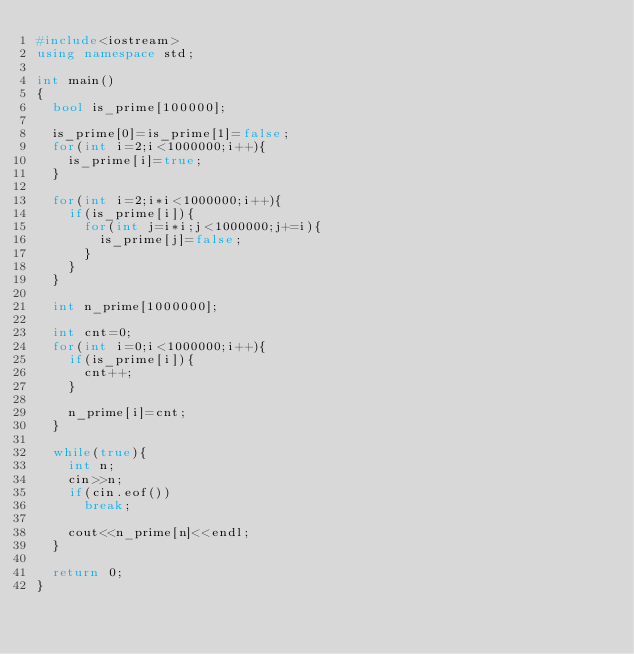Convert code to text. <code><loc_0><loc_0><loc_500><loc_500><_C++_>#include<iostream>
using namespace std;

int main()
{
	bool is_prime[100000];
	
	is_prime[0]=is_prime[1]=false;
	for(int i=2;i<1000000;i++){
		is_prime[i]=true;
	}
	
	for(int i=2;i*i<1000000;i++){
		if(is_prime[i]){
			for(int j=i*i;j<1000000;j+=i){
				is_prime[j]=false;
			}
		}
	}
	
	int n_prime[1000000];
	
	int cnt=0;
	for(int i=0;i<1000000;i++){
		if(is_prime[i]){
			cnt++;
		}
		
		n_prime[i]=cnt;
	}
	
	while(true){
		int n;
		cin>>n;
		if(cin.eof())
			break;
		
		cout<<n_prime[n]<<endl;
	}
	
	return 0;
}</code> 